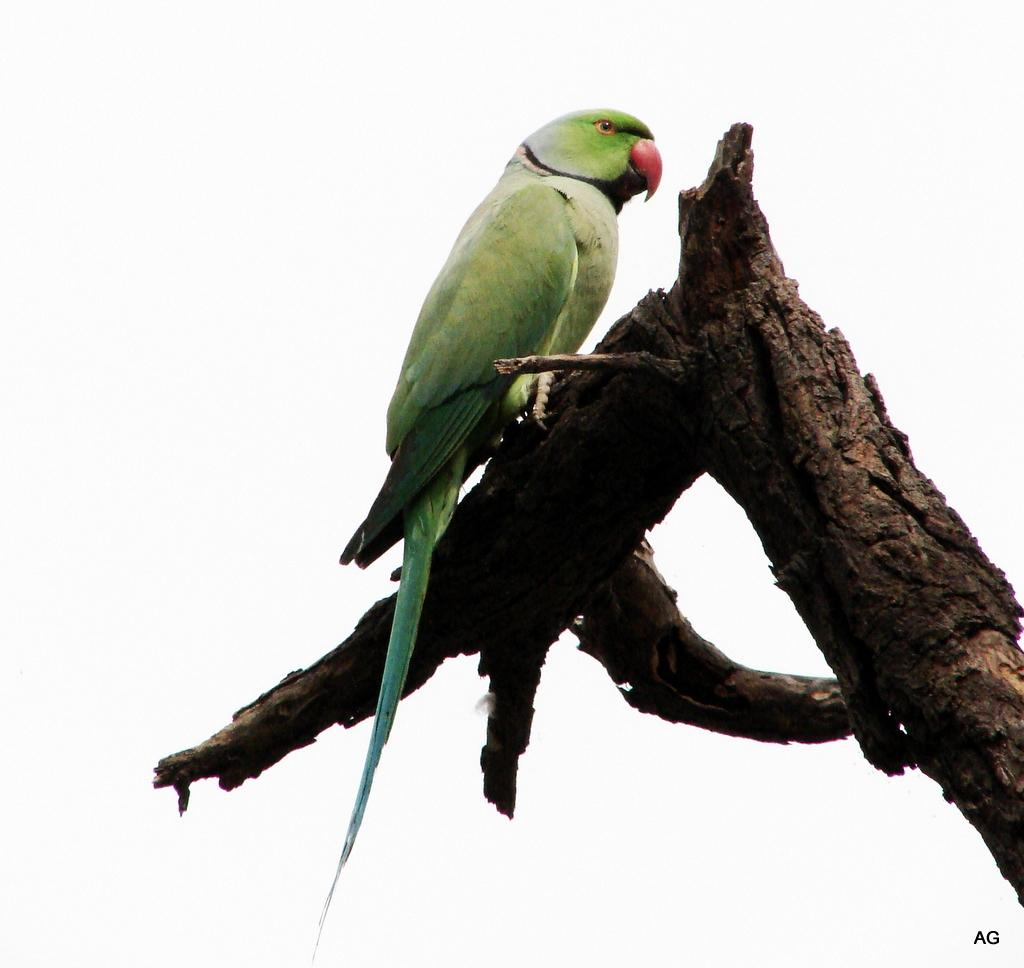What type of animal is in the image? There is a green parrot in the image. Where is the parrot located in the image? The parrot is standing on a tree branch. What brand of toothpaste is the parrot using in the image? There is no toothpaste present in the image, and the parrot is not using any toothpaste. 